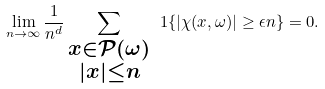Convert formula to latex. <formula><loc_0><loc_0><loc_500><loc_500>\lim _ { n \to \infty } \frac { 1 } { n ^ { d } } \sum _ { \substack { x \in \mathcal { P } ( \omega ) \\ | x | \leq n } } \ 1 { \{ | \chi ( x , \omega ) | \geq \epsilon n \} } = 0 .</formula> 